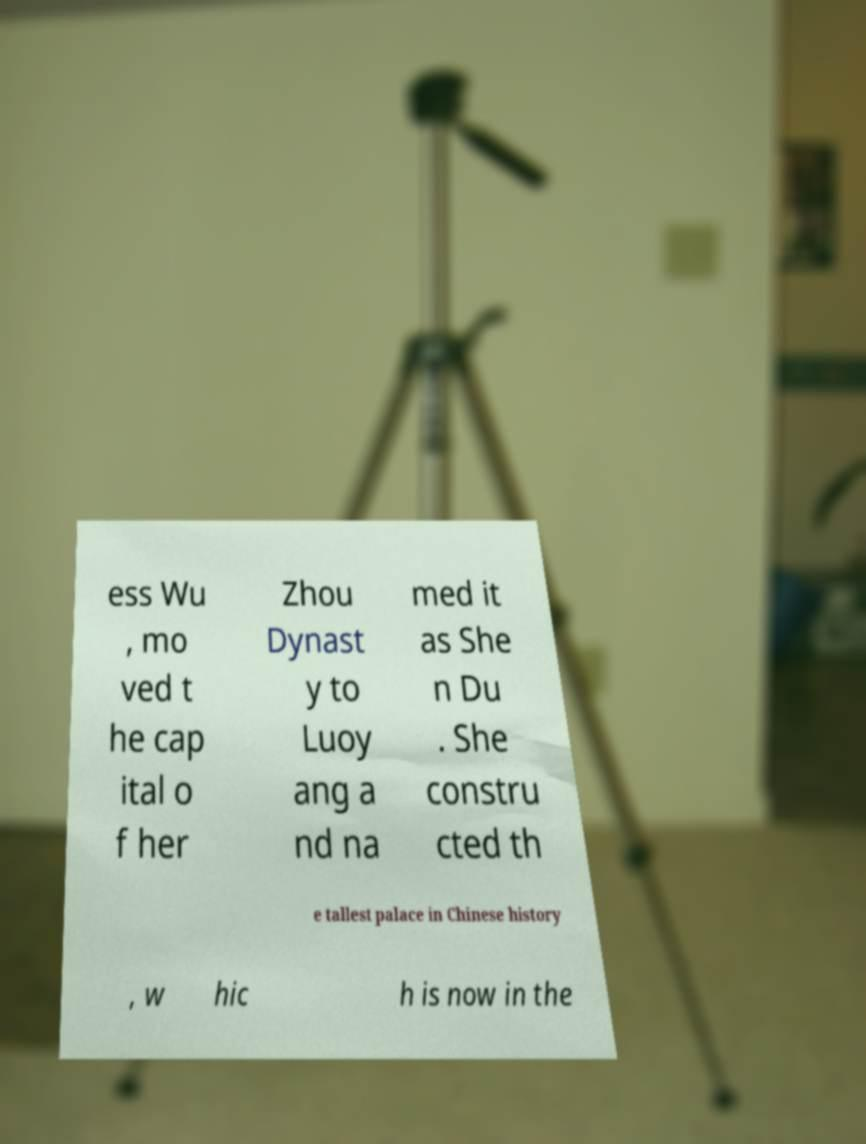There's text embedded in this image that I need extracted. Can you transcribe it verbatim? ess Wu , mo ved t he cap ital o f her Zhou Dynast y to Luoy ang a nd na med it as She n Du . She constru cted th e tallest palace in Chinese history , w hic h is now in the 